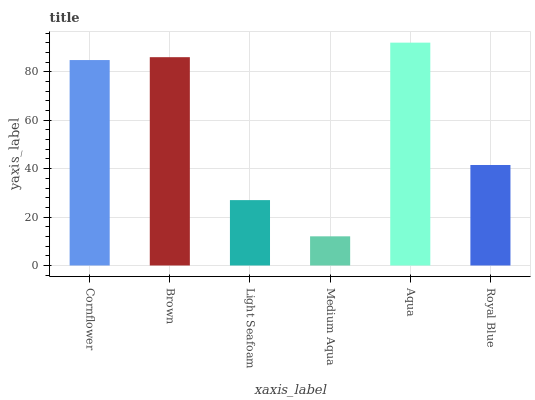Is Brown the minimum?
Answer yes or no. No. Is Brown the maximum?
Answer yes or no. No. Is Brown greater than Cornflower?
Answer yes or no. Yes. Is Cornflower less than Brown?
Answer yes or no. Yes. Is Cornflower greater than Brown?
Answer yes or no. No. Is Brown less than Cornflower?
Answer yes or no. No. Is Cornflower the high median?
Answer yes or no. Yes. Is Royal Blue the low median?
Answer yes or no. Yes. Is Light Seafoam the high median?
Answer yes or no. No. Is Medium Aqua the low median?
Answer yes or no. No. 